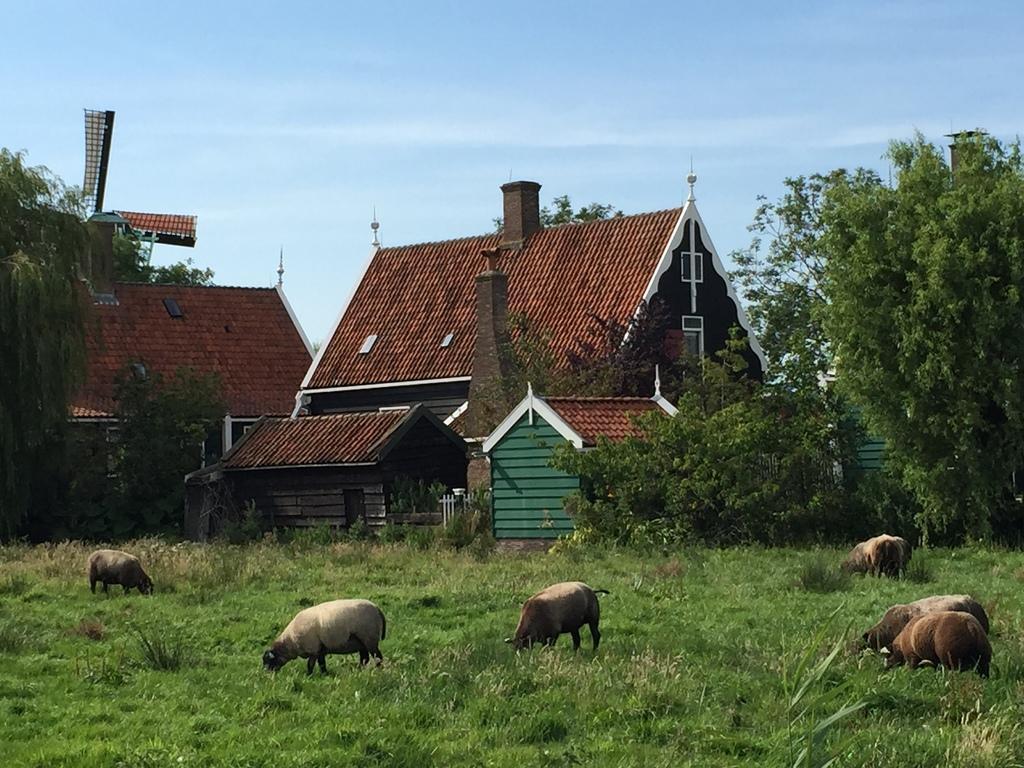Please provide a concise description of this image. In this image I can see few animals, they are in brown and cream color. The animals are eating grass, background I can see few trees and grass in green color, few houses in brown color and the sky is in blue color. 